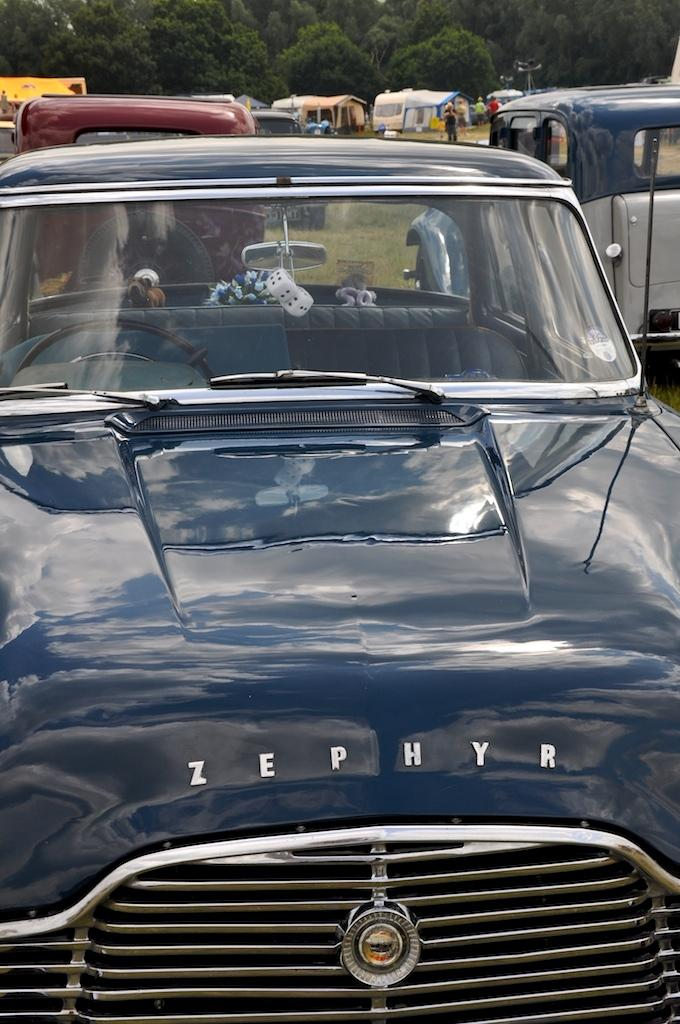What type of vehicles are on the ground in the image? There are cars on the ground in the image. What can be seen in the background of the image? There is a house, people, and trees in the background of the image. How many cattle are grazing in the background of the image? There are no cattle present in the image; it features cars on the ground, a house, people, and trees in the background. 